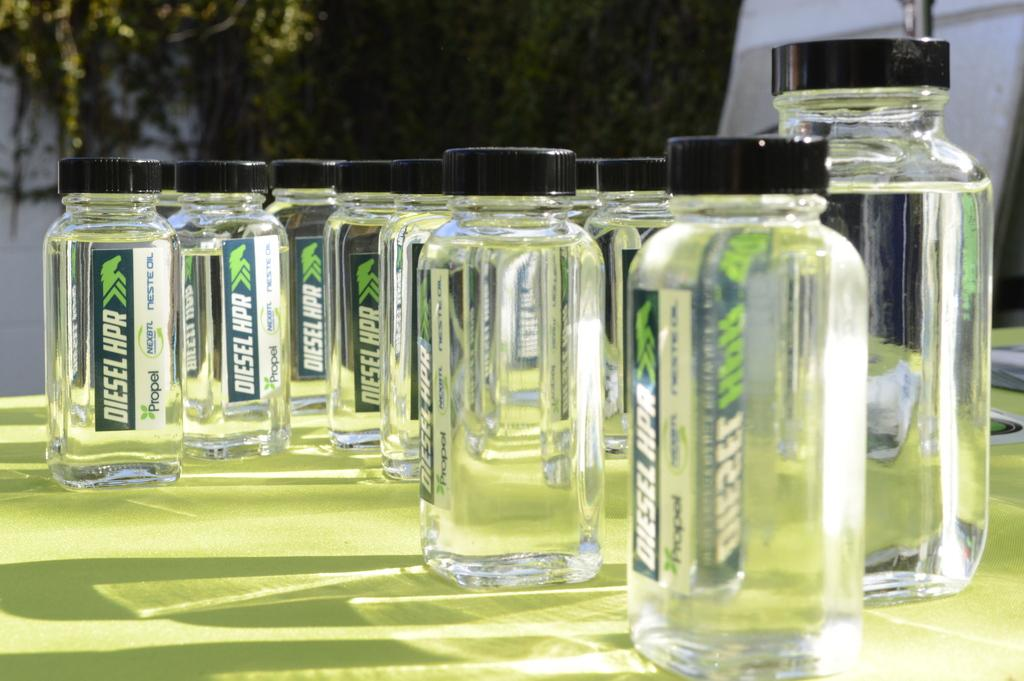<image>
Describe the image concisely. Man tiny bottles including one that says Diesel HPR. 